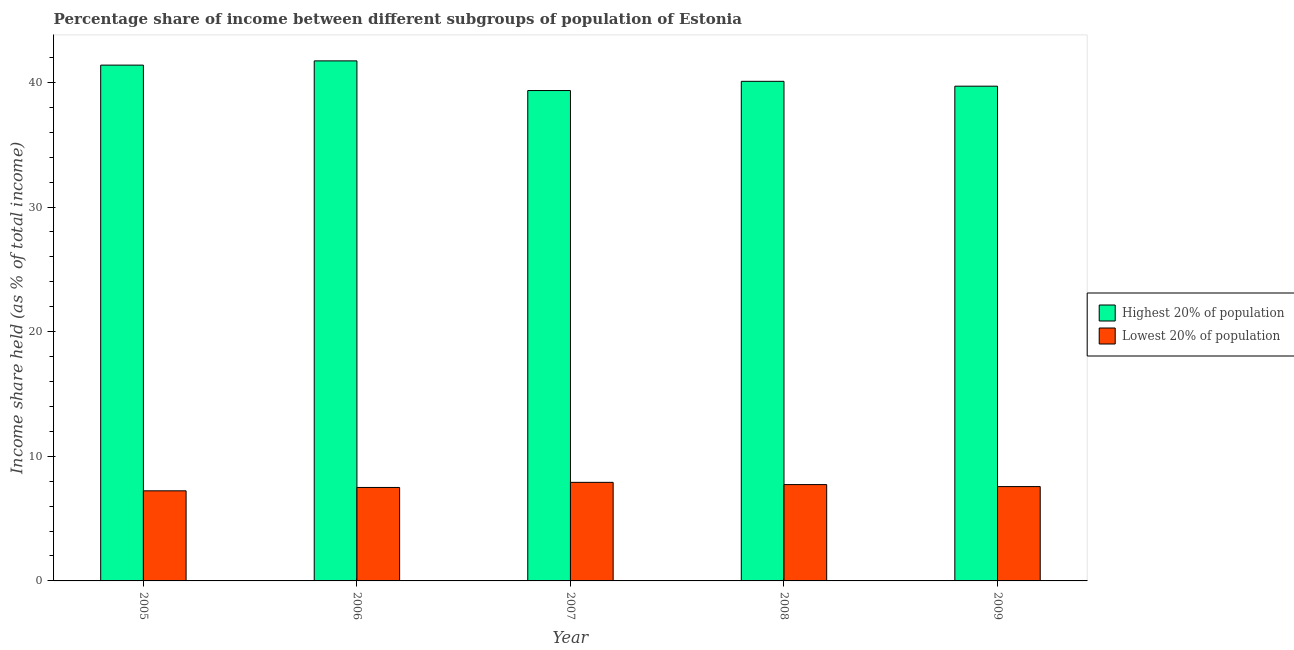Are the number of bars per tick equal to the number of legend labels?
Keep it short and to the point. Yes. Are the number of bars on each tick of the X-axis equal?
Your answer should be compact. Yes. What is the label of the 3rd group of bars from the left?
Offer a terse response. 2007. What is the income share held by highest 20% of the population in 2006?
Your answer should be very brief. 41.73. Across all years, what is the maximum income share held by highest 20% of the population?
Provide a succinct answer. 41.73. Across all years, what is the minimum income share held by lowest 20% of the population?
Give a very brief answer. 7.23. In which year was the income share held by highest 20% of the population maximum?
Offer a very short reply. 2006. In which year was the income share held by lowest 20% of the population minimum?
Offer a terse response. 2005. What is the total income share held by highest 20% of the population in the graph?
Your answer should be very brief. 202.26. What is the difference between the income share held by highest 20% of the population in 2007 and that in 2008?
Your response must be concise. -0.74. What is the difference between the income share held by highest 20% of the population in 2009 and the income share held by lowest 20% of the population in 2007?
Offer a very short reply. 0.35. What is the average income share held by highest 20% of the population per year?
Keep it short and to the point. 40.45. In the year 2008, what is the difference between the income share held by highest 20% of the population and income share held by lowest 20% of the population?
Offer a terse response. 0. In how many years, is the income share held by highest 20% of the population greater than 40 %?
Offer a terse response. 3. What is the ratio of the income share held by lowest 20% of the population in 2005 to that in 2007?
Keep it short and to the point. 0.91. Is the income share held by highest 20% of the population in 2005 less than that in 2009?
Offer a terse response. No. What is the difference between the highest and the second highest income share held by lowest 20% of the population?
Provide a short and direct response. 0.18. What is the difference between the highest and the lowest income share held by lowest 20% of the population?
Make the answer very short. 0.68. In how many years, is the income share held by lowest 20% of the population greater than the average income share held by lowest 20% of the population taken over all years?
Ensure brevity in your answer.  2. What does the 2nd bar from the left in 2009 represents?
Make the answer very short. Lowest 20% of population. What does the 2nd bar from the right in 2006 represents?
Give a very brief answer. Highest 20% of population. How many bars are there?
Offer a very short reply. 10. What is the difference between two consecutive major ticks on the Y-axis?
Give a very brief answer. 10. Does the graph contain any zero values?
Your answer should be compact. No. Does the graph contain grids?
Provide a short and direct response. No. Where does the legend appear in the graph?
Provide a succinct answer. Center right. How many legend labels are there?
Offer a terse response. 2. How are the legend labels stacked?
Offer a very short reply. Vertical. What is the title of the graph?
Your answer should be compact. Percentage share of income between different subgroups of population of Estonia. Does "Overweight" appear as one of the legend labels in the graph?
Offer a very short reply. No. What is the label or title of the X-axis?
Your answer should be compact. Year. What is the label or title of the Y-axis?
Offer a terse response. Income share held (as % of total income). What is the Income share held (as % of total income) of Highest 20% of population in 2005?
Offer a terse response. 41.39. What is the Income share held (as % of total income) in Lowest 20% of population in 2005?
Provide a short and direct response. 7.23. What is the Income share held (as % of total income) of Highest 20% of population in 2006?
Keep it short and to the point. 41.73. What is the Income share held (as % of total income) of Lowest 20% of population in 2006?
Ensure brevity in your answer.  7.5. What is the Income share held (as % of total income) of Highest 20% of population in 2007?
Your answer should be compact. 39.35. What is the Income share held (as % of total income) in Lowest 20% of population in 2007?
Ensure brevity in your answer.  7.91. What is the Income share held (as % of total income) of Highest 20% of population in 2008?
Provide a succinct answer. 40.09. What is the Income share held (as % of total income) in Lowest 20% of population in 2008?
Your answer should be very brief. 7.73. What is the Income share held (as % of total income) in Highest 20% of population in 2009?
Offer a very short reply. 39.7. What is the Income share held (as % of total income) in Lowest 20% of population in 2009?
Provide a succinct answer. 7.57. Across all years, what is the maximum Income share held (as % of total income) of Highest 20% of population?
Keep it short and to the point. 41.73. Across all years, what is the maximum Income share held (as % of total income) of Lowest 20% of population?
Keep it short and to the point. 7.91. Across all years, what is the minimum Income share held (as % of total income) in Highest 20% of population?
Provide a short and direct response. 39.35. Across all years, what is the minimum Income share held (as % of total income) of Lowest 20% of population?
Your response must be concise. 7.23. What is the total Income share held (as % of total income) in Highest 20% of population in the graph?
Give a very brief answer. 202.26. What is the total Income share held (as % of total income) in Lowest 20% of population in the graph?
Provide a succinct answer. 37.94. What is the difference between the Income share held (as % of total income) of Highest 20% of population in 2005 and that in 2006?
Your answer should be very brief. -0.34. What is the difference between the Income share held (as % of total income) in Lowest 20% of population in 2005 and that in 2006?
Provide a short and direct response. -0.27. What is the difference between the Income share held (as % of total income) in Highest 20% of population in 2005 and that in 2007?
Ensure brevity in your answer.  2.04. What is the difference between the Income share held (as % of total income) in Lowest 20% of population in 2005 and that in 2007?
Ensure brevity in your answer.  -0.68. What is the difference between the Income share held (as % of total income) in Highest 20% of population in 2005 and that in 2008?
Make the answer very short. 1.3. What is the difference between the Income share held (as % of total income) in Lowest 20% of population in 2005 and that in 2008?
Offer a terse response. -0.5. What is the difference between the Income share held (as % of total income) of Highest 20% of population in 2005 and that in 2009?
Your answer should be compact. 1.69. What is the difference between the Income share held (as % of total income) of Lowest 20% of population in 2005 and that in 2009?
Offer a very short reply. -0.34. What is the difference between the Income share held (as % of total income) of Highest 20% of population in 2006 and that in 2007?
Give a very brief answer. 2.38. What is the difference between the Income share held (as % of total income) in Lowest 20% of population in 2006 and that in 2007?
Make the answer very short. -0.41. What is the difference between the Income share held (as % of total income) of Highest 20% of population in 2006 and that in 2008?
Offer a very short reply. 1.64. What is the difference between the Income share held (as % of total income) in Lowest 20% of population in 2006 and that in 2008?
Offer a terse response. -0.23. What is the difference between the Income share held (as % of total income) in Highest 20% of population in 2006 and that in 2009?
Provide a succinct answer. 2.03. What is the difference between the Income share held (as % of total income) in Lowest 20% of population in 2006 and that in 2009?
Your answer should be very brief. -0.07. What is the difference between the Income share held (as % of total income) in Highest 20% of population in 2007 and that in 2008?
Provide a succinct answer. -0.74. What is the difference between the Income share held (as % of total income) in Lowest 20% of population in 2007 and that in 2008?
Ensure brevity in your answer.  0.18. What is the difference between the Income share held (as % of total income) of Highest 20% of population in 2007 and that in 2009?
Offer a very short reply. -0.35. What is the difference between the Income share held (as % of total income) in Lowest 20% of population in 2007 and that in 2009?
Give a very brief answer. 0.34. What is the difference between the Income share held (as % of total income) in Highest 20% of population in 2008 and that in 2009?
Offer a very short reply. 0.39. What is the difference between the Income share held (as % of total income) in Lowest 20% of population in 2008 and that in 2009?
Provide a succinct answer. 0.16. What is the difference between the Income share held (as % of total income) of Highest 20% of population in 2005 and the Income share held (as % of total income) of Lowest 20% of population in 2006?
Provide a short and direct response. 33.89. What is the difference between the Income share held (as % of total income) in Highest 20% of population in 2005 and the Income share held (as % of total income) in Lowest 20% of population in 2007?
Give a very brief answer. 33.48. What is the difference between the Income share held (as % of total income) of Highest 20% of population in 2005 and the Income share held (as % of total income) of Lowest 20% of population in 2008?
Make the answer very short. 33.66. What is the difference between the Income share held (as % of total income) in Highest 20% of population in 2005 and the Income share held (as % of total income) in Lowest 20% of population in 2009?
Give a very brief answer. 33.82. What is the difference between the Income share held (as % of total income) in Highest 20% of population in 2006 and the Income share held (as % of total income) in Lowest 20% of population in 2007?
Your response must be concise. 33.82. What is the difference between the Income share held (as % of total income) in Highest 20% of population in 2006 and the Income share held (as % of total income) in Lowest 20% of population in 2009?
Your response must be concise. 34.16. What is the difference between the Income share held (as % of total income) of Highest 20% of population in 2007 and the Income share held (as % of total income) of Lowest 20% of population in 2008?
Your answer should be very brief. 31.62. What is the difference between the Income share held (as % of total income) of Highest 20% of population in 2007 and the Income share held (as % of total income) of Lowest 20% of population in 2009?
Give a very brief answer. 31.78. What is the difference between the Income share held (as % of total income) of Highest 20% of population in 2008 and the Income share held (as % of total income) of Lowest 20% of population in 2009?
Provide a succinct answer. 32.52. What is the average Income share held (as % of total income) of Highest 20% of population per year?
Your answer should be very brief. 40.45. What is the average Income share held (as % of total income) in Lowest 20% of population per year?
Your answer should be very brief. 7.59. In the year 2005, what is the difference between the Income share held (as % of total income) in Highest 20% of population and Income share held (as % of total income) in Lowest 20% of population?
Provide a short and direct response. 34.16. In the year 2006, what is the difference between the Income share held (as % of total income) in Highest 20% of population and Income share held (as % of total income) in Lowest 20% of population?
Your answer should be very brief. 34.23. In the year 2007, what is the difference between the Income share held (as % of total income) in Highest 20% of population and Income share held (as % of total income) in Lowest 20% of population?
Offer a very short reply. 31.44. In the year 2008, what is the difference between the Income share held (as % of total income) of Highest 20% of population and Income share held (as % of total income) of Lowest 20% of population?
Keep it short and to the point. 32.36. In the year 2009, what is the difference between the Income share held (as % of total income) of Highest 20% of population and Income share held (as % of total income) of Lowest 20% of population?
Give a very brief answer. 32.13. What is the ratio of the Income share held (as % of total income) of Lowest 20% of population in 2005 to that in 2006?
Make the answer very short. 0.96. What is the ratio of the Income share held (as % of total income) in Highest 20% of population in 2005 to that in 2007?
Make the answer very short. 1.05. What is the ratio of the Income share held (as % of total income) of Lowest 20% of population in 2005 to that in 2007?
Give a very brief answer. 0.91. What is the ratio of the Income share held (as % of total income) of Highest 20% of population in 2005 to that in 2008?
Provide a succinct answer. 1.03. What is the ratio of the Income share held (as % of total income) of Lowest 20% of population in 2005 to that in 2008?
Keep it short and to the point. 0.94. What is the ratio of the Income share held (as % of total income) in Highest 20% of population in 2005 to that in 2009?
Keep it short and to the point. 1.04. What is the ratio of the Income share held (as % of total income) of Lowest 20% of population in 2005 to that in 2009?
Make the answer very short. 0.96. What is the ratio of the Income share held (as % of total income) in Highest 20% of population in 2006 to that in 2007?
Offer a very short reply. 1.06. What is the ratio of the Income share held (as % of total income) of Lowest 20% of population in 2006 to that in 2007?
Keep it short and to the point. 0.95. What is the ratio of the Income share held (as % of total income) of Highest 20% of population in 2006 to that in 2008?
Make the answer very short. 1.04. What is the ratio of the Income share held (as % of total income) of Lowest 20% of population in 2006 to that in 2008?
Provide a short and direct response. 0.97. What is the ratio of the Income share held (as % of total income) in Highest 20% of population in 2006 to that in 2009?
Offer a terse response. 1.05. What is the ratio of the Income share held (as % of total income) of Lowest 20% of population in 2006 to that in 2009?
Offer a terse response. 0.99. What is the ratio of the Income share held (as % of total income) in Highest 20% of population in 2007 to that in 2008?
Make the answer very short. 0.98. What is the ratio of the Income share held (as % of total income) in Lowest 20% of population in 2007 to that in 2008?
Offer a very short reply. 1.02. What is the ratio of the Income share held (as % of total income) in Highest 20% of population in 2007 to that in 2009?
Your response must be concise. 0.99. What is the ratio of the Income share held (as % of total income) of Lowest 20% of population in 2007 to that in 2009?
Keep it short and to the point. 1.04. What is the ratio of the Income share held (as % of total income) of Highest 20% of population in 2008 to that in 2009?
Offer a terse response. 1.01. What is the ratio of the Income share held (as % of total income) in Lowest 20% of population in 2008 to that in 2009?
Your response must be concise. 1.02. What is the difference between the highest and the second highest Income share held (as % of total income) in Highest 20% of population?
Give a very brief answer. 0.34. What is the difference between the highest and the second highest Income share held (as % of total income) of Lowest 20% of population?
Provide a succinct answer. 0.18. What is the difference between the highest and the lowest Income share held (as % of total income) in Highest 20% of population?
Your answer should be very brief. 2.38. What is the difference between the highest and the lowest Income share held (as % of total income) in Lowest 20% of population?
Ensure brevity in your answer.  0.68. 